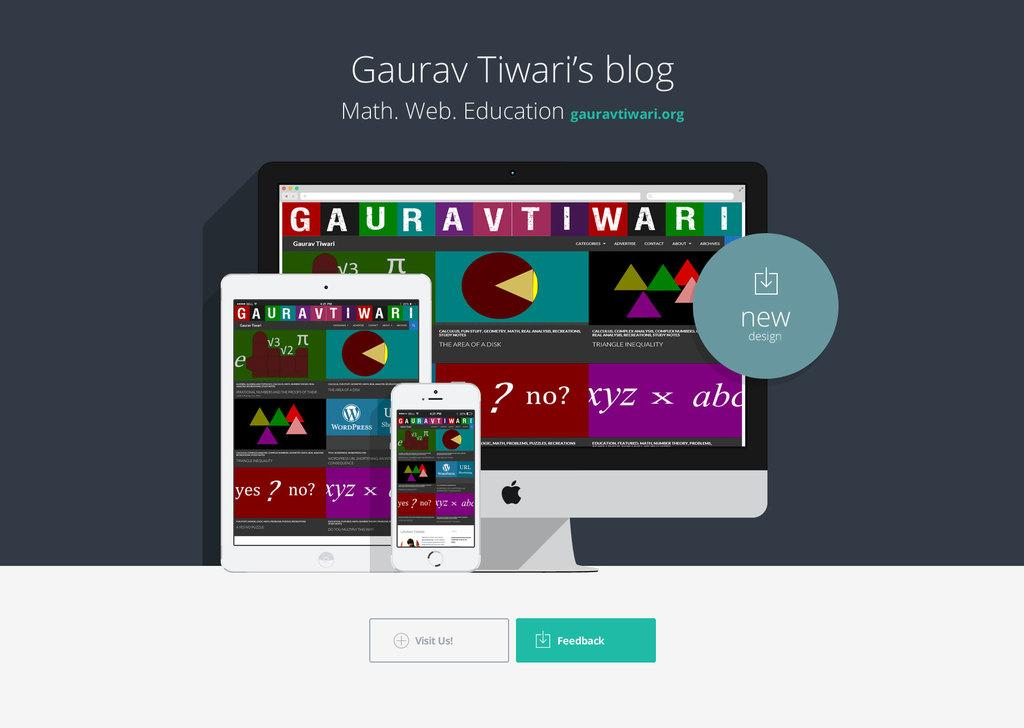Provide a one-sentence caption for the provided image. A graphic advertising Gaurav Tiwari's blog with an iphone, ipad, and apple desktop computer. 